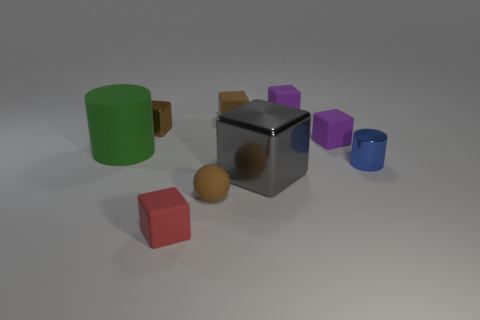Subtract all brown metal cubes. How many cubes are left? 5 Add 1 tiny purple matte objects. How many objects exist? 10 Subtract all cubes. How many objects are left? 3 Subtract 1 cylinders. How many cylinders are left? 1 Subtract all brown cubes. How many cubes are left? 4 Subtract all red cylinders. How many brown blocks are left? 2 Subtract all blue metallic objects. Subtract all large red cubes. How many objects are left? 8 Add 2 large green cylinders. How many large green cylinders are left? 3 Add 4 matte objects. How many matte objects exist? 10 Subtract 0 red cylinders. How many objects are left? 9 